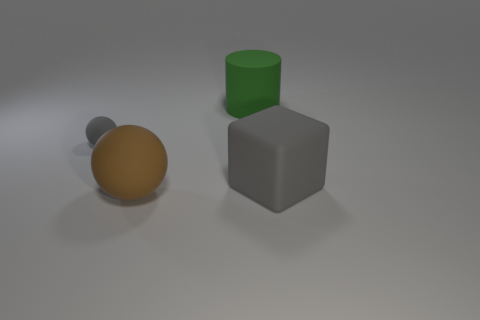Subtract all gray balls. How many balls are left? 1 Add 4 matte objects. How many objects exist? 8 Subtract 1 cylinders. How many cylinders are left? 0 Subtract all blocks. How many objects are left? 3 Subtract all blue spheres. Subtract all gray blocks. How many spheres are left? 2 Subtract all green cylinders. How many gray spheres are left? 1 Subtract all purple blocks. Subtract all gray rubber things. How many objects are left? 2 Add 3 blocks. How many blocks are left? 4 Add 2 matte cylinders. How many matte cylinders exist? 3 Subtract 0 blue blocks. How many objects are left? 4 